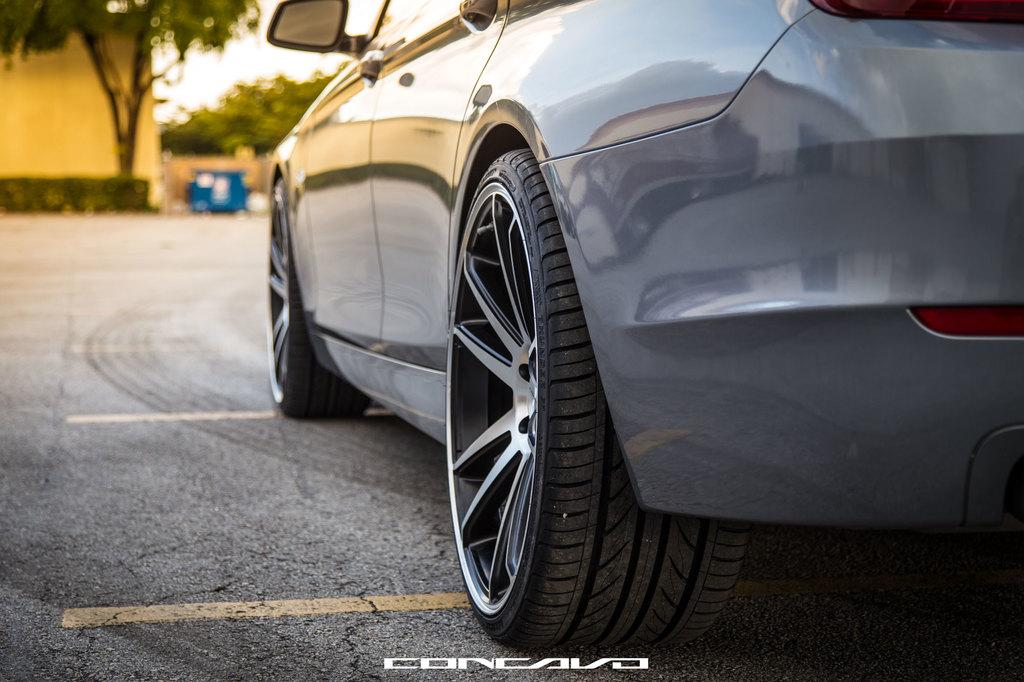What is the main subject of the image? There is a car on a road in the image. What can be seen in the background of the image? There are trees visible in the background of the image. How would you describe the appearance of the background? The background appears blurred. What information is provided at the bottom of the image? There is text at the bottom of the image. Can you tell me how many cribs are visible in the image? There are no cribs present in the image. What type of attack is being carried out in the image? There is no attack or any form of violence depicted in the image. 